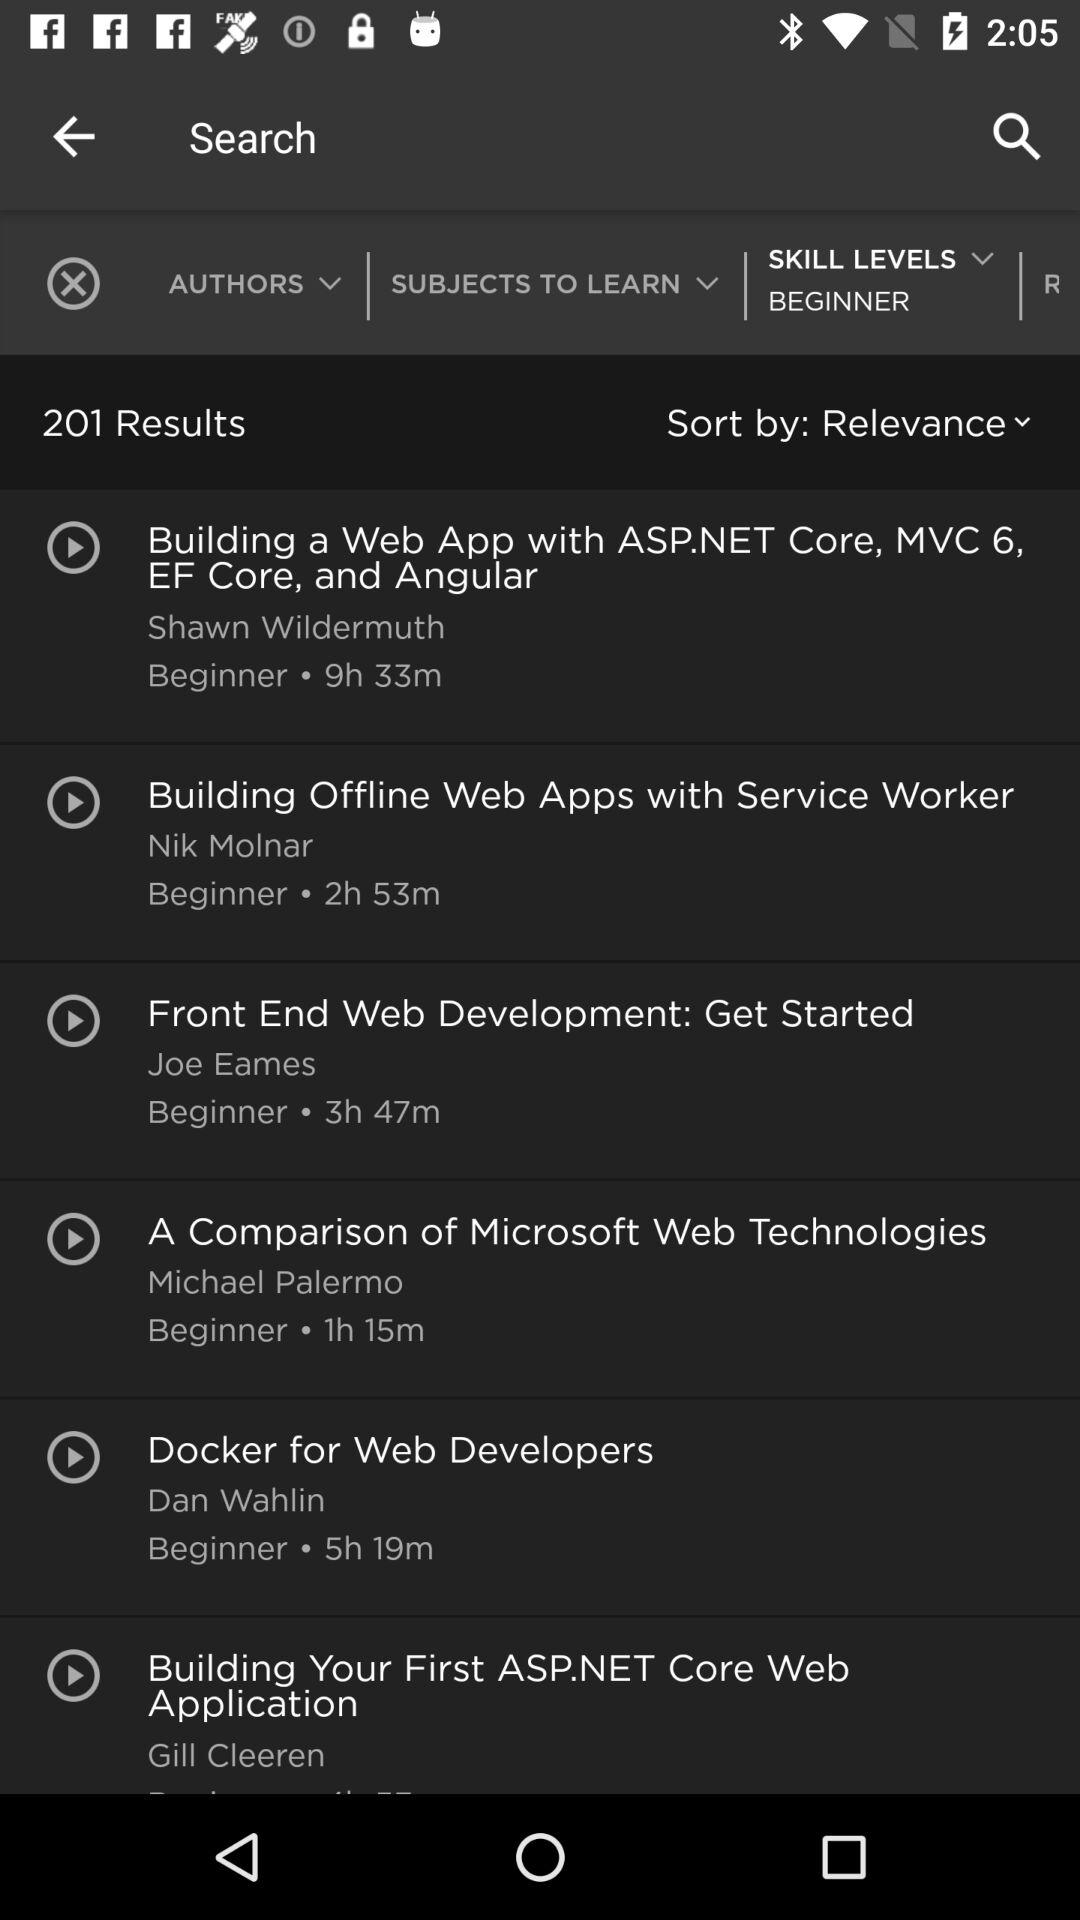What is the name of the video whose duration is 5 hours and 19 minutes? The name of the video is "Docker for Web Developers". 